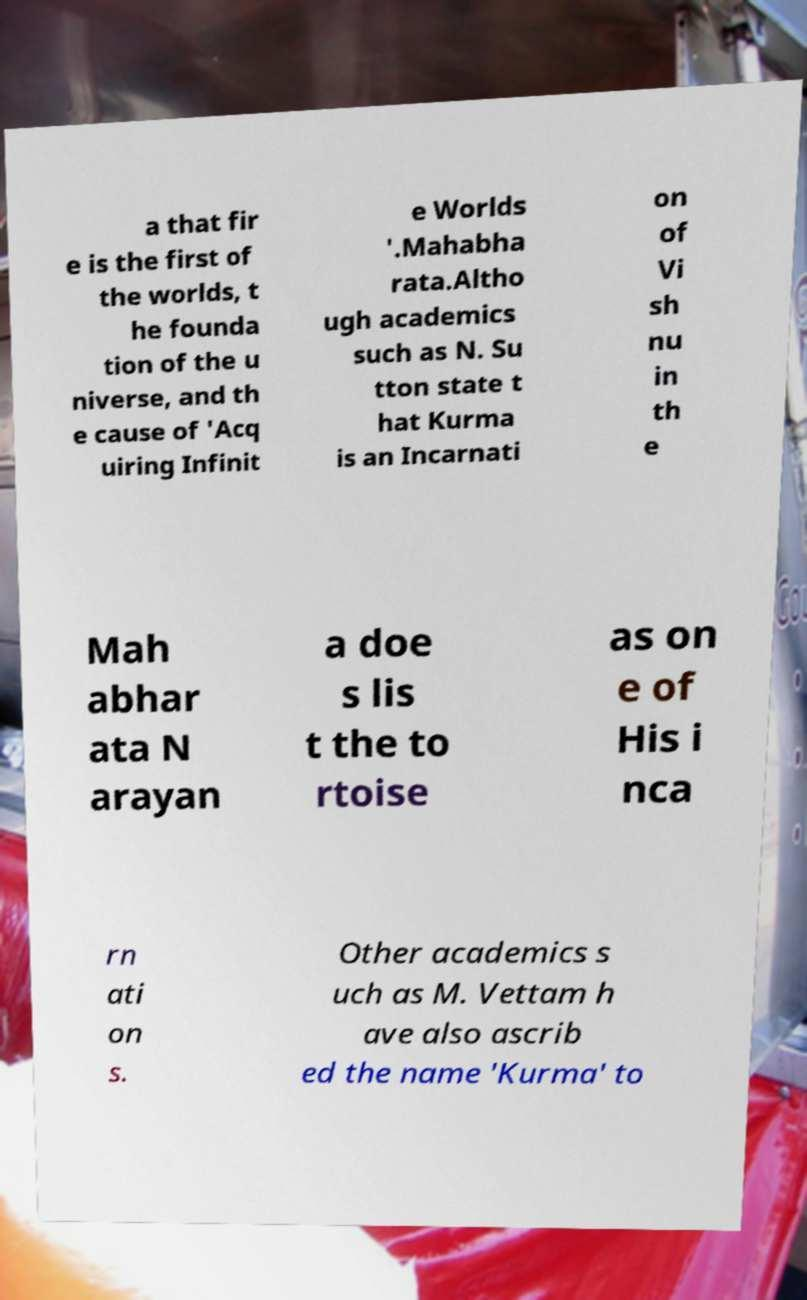Please read and relay the text visible in this image. What does it say? a that fir e is the first of the worlds, t he founda tion of the u niverse, and th e cause of 'Acq uiring Infinit e Worlds '.Mahabha rata.Altho ugh academics such as N. Su tton state t hat Kurma is an Incarnati on of Vi sh nu in th e Mah abhar ata N arayan a doe s lis t the to rtoise as on e of His i nca rn ati on s. Other academics s uch as M. Vettam h ave also ascrib ed the name 'Kurma' to 